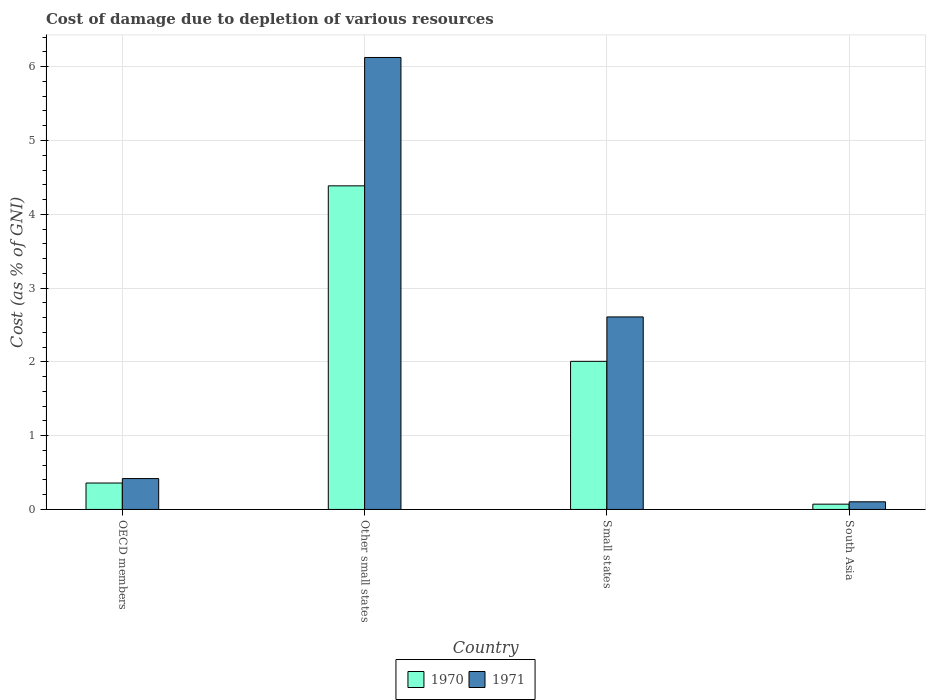How many groups of bars are there?
Provide a short and direct response. 4. Are the number of bars per tick equal to the number of legend labels?
Your answer should be compact. Yes. How many bars are there on the 1st tick from the left?
Your response must be concise. 2. What is the label of the 2nd group of bars from the left?
Give a very brief answer. Other small states. What is the cost of damage caused due to the depletion of various resources in 1971 in OECD members?
Give a very brief answer. 0.42. Across all countries, what is the maximum cost of damage caused due to the depletion of various resources in 1971?
Keep it short and to the point. 6.13. Across all countries, what is the minimum cost of damage caused due to the depletion of various resources in 1970?
Your response must be concise. 0.07. In which country was the cost of damage caused due to the depletion of various resources in 1970 maximum?
Offer a terse response. Other small states. In which country was the cost of damage caused due to the depletion of various resources in 1970 minimum?
Ensure brevity in your answer.  South Asia. What is the total cost of damage caused due to the depletion of various resources in 1971 in the graph?
Your answer should be very brief. 9.26. What is the difference between the cost of damage caused due to the depletion of various resources in 1970 in Other small states and that in South Asia?
Your response must be concise. 4.31. What is the difference between the cost of damage caused due to the depletion of various resources in 1970 in South Asia and the cost of damage caused due to the depletion of various resources in 1971 in Small states?
Provide a short and direct response. -2.54. What is the average cost of damage caused due to the depletion of various resources in 1971 per country?
Offer a very short reply. 2.31. What is the difference between the cost of damage caused due to the depletion of various resources of/in 1971 and cost of damage caused due to the depletion of various resources of/in 1970 in South Asia?
Your answer should be compact. 0.03. What is the ratio of the cost of damage caused due to the depletion of various resources in 1971 in Small states to that in South Asia?
Offer a terse response. 25.17. What is the difference between the highest and the second highest cost of damage caused due to the depletion of various resources in 1970?
Your response must be concise. -1.65. What is the difference between the highest and the lowest cost of damage caused due to the depletion of various resources in 1970?
Provide a succinct answer. 4.31. Is the sum of the cost of damage caused due to the depletion of various resources in 1970 in OECD members and Small states greater than the maximum cost of damage caused due to the depletion of various resources in 1971 across all countries?
Provide a succinct answer. No. What does the 1st bar from the left in OECD members represents?
Ensure brevity in your answer.  1970. What does the 2nd bar from the right in Other small states represents?
Provide a succinct answer. 1970. How many bars are there?
Give a very brief answer. 8. Are all the bars in the graph horizontal?
Your answer should be compact. No. How many countries are there in the graph?
Your answer should be very brief. 4. Are the values on the major ticks of Y-axis written in scientific E-notation?
Offer a terse response. No. Does the graph contain grids?
Give a very brief answer. Yes. Where does the legend appear in the graph?
Offer a terse response. Bottom center. How many legend labels are there?
Offer a very short reply. 2. How are the legend labels stacked?
Offer a terse response. Horizontal. What is the title of the graph?
Make the answer very short. Cost of damage due to depletion of various resources. Does "2011" appear as one of the legend labels in the graph?
Ensure brevity in your answer.  No. What is the label or title of the Y-axis?
Provide a succinct answer. Cost (as % of GNI). What is the Cost (as % of GNI) of 1970 in OECD members?
Offer a terse response. 0.36. What is the Cost (as % of GNI) in 1971 in OECD members?
Provide a succinct answer. 0.42. What is the Cost (as % of GNI) in 1970 in Other small states?
Offer a terse response. 4.39. What is the Cost (as % of GNI) in 1971 in Other small states?
Your response must be concise. 6.13. What is the Cost (as % of GNI) of 1970 in Small states?
Offer a very short reply. 2.01. What is the Cost (as % of GNI) of 1971 in Small states?
Offer a terse response. 2.61. What is the Cost (as % of GNI) of 1970 in South Asia?
Provide a short and direct response. 0.07. What is the Cost (as % of GNI) of 1971 in South Asia?
Make the answer very short. 0.1. Across all countries, what is the maximum Cost (as % of GNI) in 1970?
Keep it short and to the point. 4.39. Across all countries, what is the maximum Cost (as % of GNI) of 1971?
Offer a very short reply. 6.13. Across all countries, what is the minimum Cost (as % of GNI) of 1970?
Offer a terse response. 0.07. Across all countries, what is the minimum Cost (as % of GNI) of 1971?
Provide a short and direct response. 0.1. What is the total Cost (as % of GNI) of 1970 in the graph?
Your response must be concise. 6.82. What is the total Cost (as % of GNI) of 1971 in the graph?
Offer a very short reply. 9.26. What is the difference between the Cost (as % of GNI) of 1970 in OECD members and that in Other small states?
Provide a short and direct response. -4.03. What is the difference between the Cost (as % of GNI) in 1971 in OECD members and that in Other small states?
Your answer should be very brief. -5.71. What is the difference between the Cost (as % of GNI) in 1970 in OECD members and that in Small states?
Your response must be concise. -1.65. What is the difference between the Cost (as % of GNI) of 1971 in OECD members and that in Small states?
Your answer should be very brief. -2.19. What is the difference between the Cost (as % of GNI) in 1970 in OECD members and that in South Asia?
Ensure brevity in your answer.  0.29. What is the difference between the Cost (as % of GNI) in 1971 in OECD members and that in South Asia?
Your answer should be compact. 0.31. What is the difference between the Cost (as % of GNI) of 1970 in Other small states and that in Small states?
Provide a succinct answer. 2.38. What is the difference between the Cost (as % of GNI) in 1971 in Other small states and that in Small states?
Your answer should be compact. 3.52. What is the difference between the Cost (as % of GNI) of 1970 in Other small states and that in South Asia?
Offer a terse response. 4.31. What is the difference between the Cost (as % of GNI) of 1971 in Other small states and that in South Asia?
Ensure brevity in your answer.  6.02. What is the difference between the Cost (as % of GNI) in 1970 in Small states and that in South Asia?
Offer a very short reply. 1.94. What is the difference between the Cost (as % of GNI) of 1971 in Small states and that in South Asia?
Give a very brief answer. 2.51. What is the difference between the Cost (as % of GNI) of 1970 in OECD members and the Cost (as % of GNI) of 1971 in Other small states?
Ensure brevity in your answer.  -5.77. What is the difference between the Cost (as % of GNI) of 1970 in OECD members and the Cost (as % of GNI) of 1971 in Small states?
Your answer should be compact. -2.25. What is the difference between the Cost (as % of GNI) of 1970 in OECD members and the Cost (as % of GNI) of 1971 in South Asia?
Ensure brevity in your answer.  0.25. What is the difference between the Cost (as % of GNI) in 1970 in Other small states and the Cost (as % of GNI) in 1971 in Small states?
Offer a terse response. 1.78. What is the difference between the Cost (as % of GNI) in 1970 in Other small states and the Cost (as % of GNI) in 1971 in South Asia?
Offer a terse response. 4.28. What is the difference between the Cost (as % of GNI) of 1970 in Small states and the Cost (as % of GNI) of 1971 in South Asia?
Your response must be concise. 1.9. What is the average Cost (as % of GNI) of 1970 per country?
Keep it short and to the point. 1.71. What is the average Cost (as % of GNI) of 1971 per country?
Provide a succinct answer. 2.31. What is the difference between the Cost (as % of GNI) of 1970 and Cost (as % of GNI) of 1971 in OECD members?
Offer a very short reply. -0.06. What is the difference between the Cost (as % of GNI) of 1970 and Cost (as % of GNI) of 1971 in Other small states?
Provide a succinct answer. -1.74. What is the difference between the Cost (as % of GNI) of 1970 and Cost (as % of GNI) of 1971 in Small states?
Provide a short and direct response. -0.6. What is the difference between the Cost (as % of GNI) of 1970 and Cost (as % of GNI) of 1971 in South Asia?
Keep it short and to the point. -0.03. What is the ratio of the Cost (as % of GNI) in 1970 in OECD members to that in Other small states?
Offer a very short reply. 0.08. What is the ratio of the Cost (as % of GNI) in 1971 in OECD members to that in Other small states?
Offer a terse response. 0.07. What is the ratio of the Cost (as % of GNI) of 1970 in OECD members to that in Small states?
Offer a very short reply. 0.18. What is the ratio of the Cost (as % of GNI) of 1971 in OECD members to that in Small states?
Your answer should be very brief. 0.16. What is the ratio of the Cost (as % of GNI) of 1970 in OECD members to that in South Asia?
Your answer should be very brief. 5. What is the ratio of the Cost (as % of GNI) in 1971 in OECD members to that in South Asia?
Provide a short and direct response. 4.04. What is the ratio of the Cost (as % of GNI) in 1970 in Other small states to that in Small states?
Ensure brevity in your answer.  2.18. What is the ratio of the Cost (as % of GNI) in 1971 in Other small states to that in Small states?
Offer a terse response. 2.35. What is the ratio of the Cost (as % of GNI) in 1970 in Other small states to that in South Asia?
Provide a short and direct response. 61.21. What is the ratio of the Cost (as % of GNI) of 1971 in Other small states to that in South Asia?
Your response must be concise. 59.08. What is the ratio of the Cost (as % of GNI) of 1970 in Small states to that in South Asia?
Your answer should be very brief. 28.02. What is the ratio of the Cost (as % of GNI) of 1971 in Small states to that in South Asia?
Offer a terse response. 25.17. What is the difference between the highest and the second highest Cost (as % of GNI) of 1970?
Provide a succinct answer. 2.38. What is the difference between the highest and the second highest Cost (as % of GNI) of 1971?
Ensure brevity in your answer.  3.52. What is the difference between the highest and the lowest Cost (as % of GNI) in 1970?
Your response must be concise. 4.31. What is the difference between the highest and the lowest Cost (as % of GNI) of 1971?
Provide a short and direct response. 6.02. 